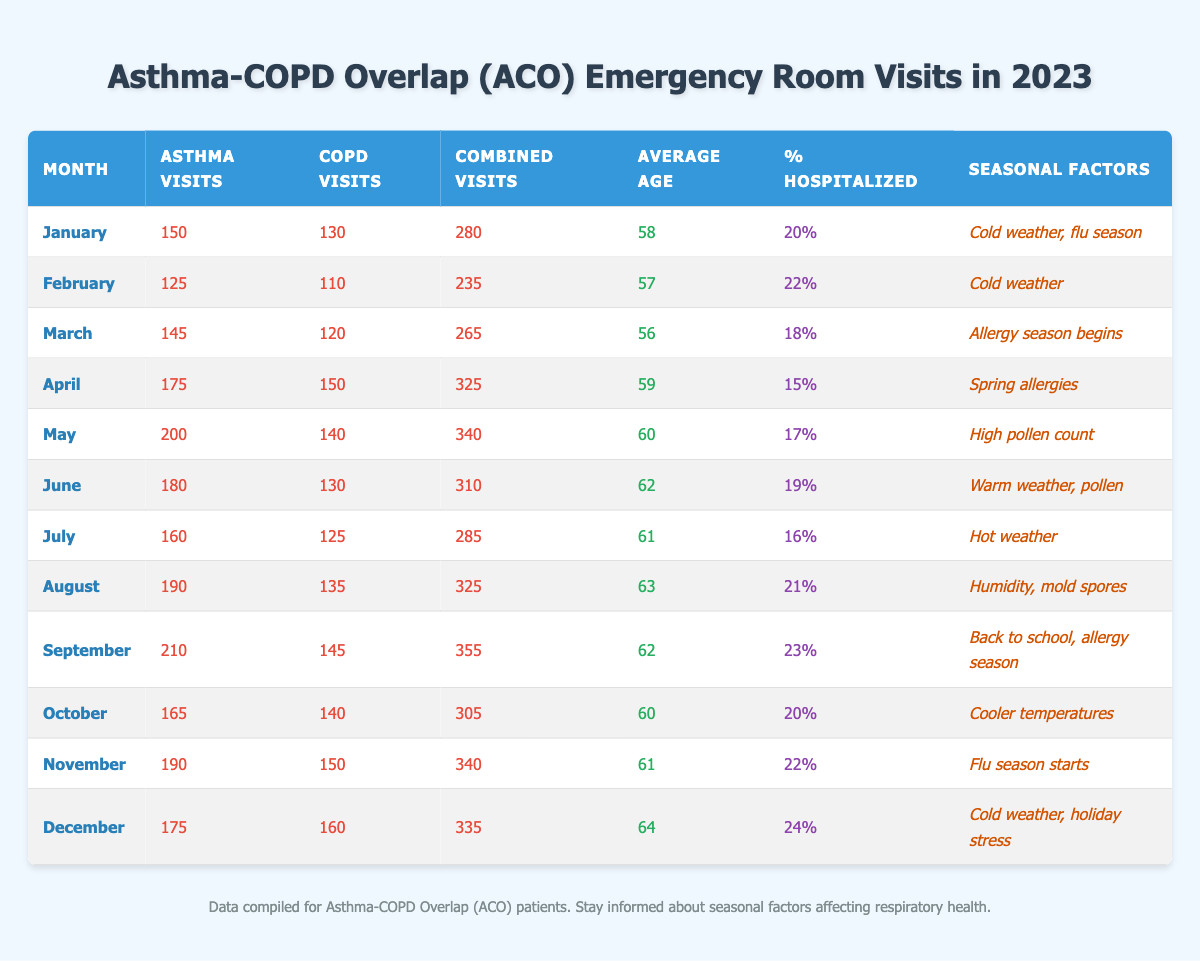What month had the highest combined visits? Looking at the "Combined Visits" column for each month, September has the highest value at 355 visits.
Answer: September What is the average age of patients for the month of June? The table shows that in June, the average age of patients was listed as 62.
Answer: 62 Was there a month where more than 20% of patients were hospitalized? By checking the "% Hospitalized" column, December (24%), September (23%), and November (22%) all had more than 20%.
Answer: Yes How many total asthma visits occurred from January to March? Adding the asthma visits: January (150) + February (125) + March (145) gives a total of 420 visits.
Answer: 420 In which month was the percentage of hospitalized patients the lowest? Looking at the "% Hospitalized" column, April has the lowest percentage at 15%.
Answer: April What were the seasonal factors during the month of August? The seasonal factors listed for August include "Humidity, mold spores".
Answer: Humidity, mold spores How many more combined visits were there in May compared to March? For May, combined visits are 340, while for March they are 265. Subtracting gives 340 - 265 = 75 more visits in May.
Answer: 75 Which month showed a decrease in asthma visits compared to the previous month? Comparing the asthma visits: January (150) to February (125), shows a decrease of 25 visits.
Answer: February Did the average age of patients increase, decrease, or stay the same from June to December? The average age for June was 62, while for December it was 64. There is an increase of 2 years.
Answer: Increased What was the total number of COPD visits from April to July? Summing the COPD visits: April (150) + May (140) + June (130) + July (125) results in a total of 545 visits.
Answer: 545 In which months did the percentage of hospitalized patients increase compared to the previous month? The percentage has increased from June (19%) to July (16%) and from August (21%) to September (23%).
Answer: July and September 